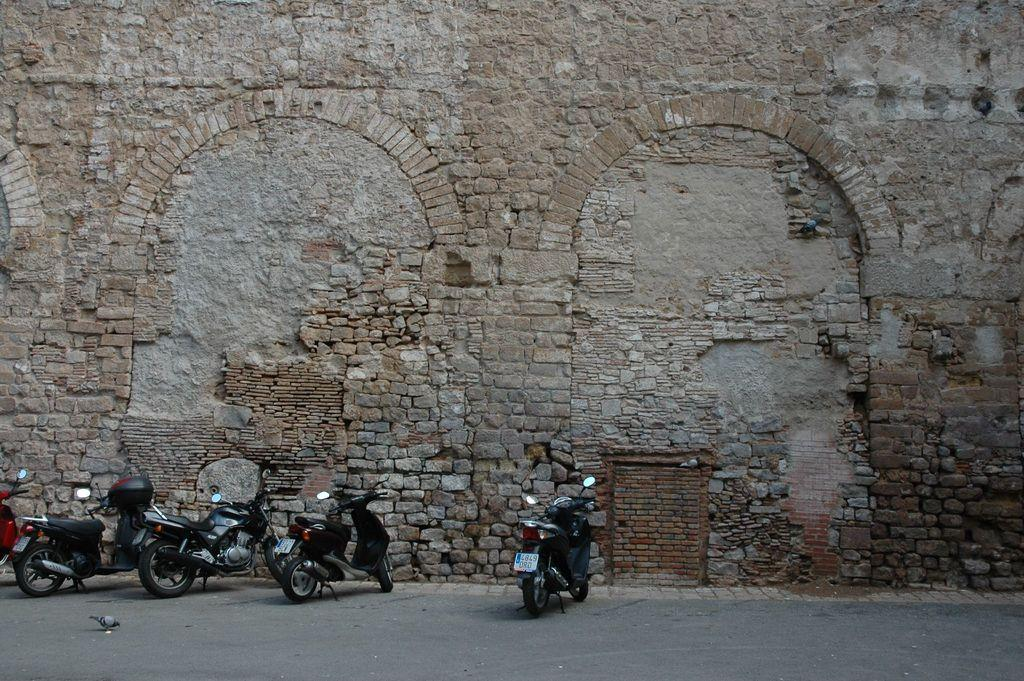What type of vehicles are on the left side of the image? There are two-wheelers on the left side of the image. What can be seen in the background of the image? There is a brick wall in the background of the image. Can you describe the appearance of the wall? The wall appears to be old. How many giants are visible in the image? There are no giants present in the image. What mark can be seen on the wall in the image? There is no specific mark mentioned in the provided facts, so it cannot be determined from the image. 